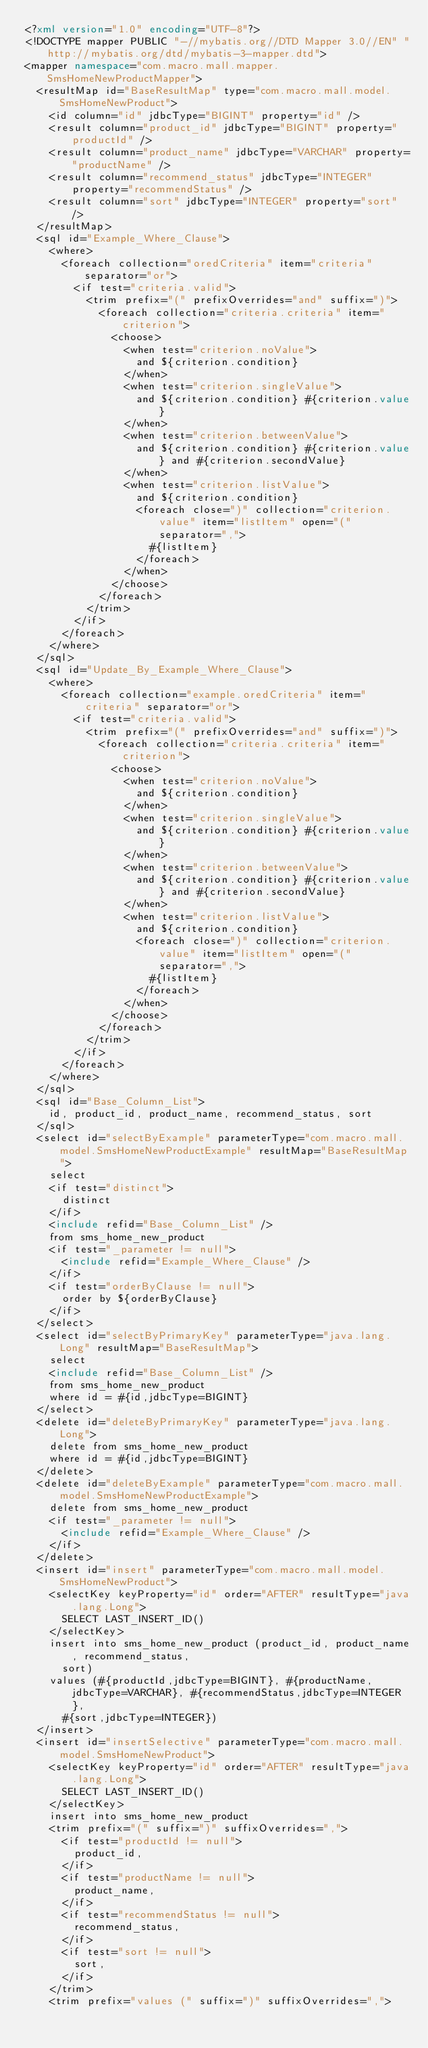<code> <loc_0><loc_0><loc_500><loc_500><_XML_><?xml version="1.0" encoding="UTF-8"?>
<!DOCTYPE mapper PUBLIC "-//mybatis.org//DTD Mapper 3.0//EN" "http://mybatis.org/dtd/mybatis-3-mapper.dtd">
<mapper namespace="com.macro.mall.mapper.SmsHomeNewProductMapper">
  <resultMap id="BaseResultMap" type="com.macro.mall.model.SmsHomeNewProduct">
    <id column="id" jdbcType="BIGINT" property="id" />
    <result column="product_id" jdbcType="BIGINT" property="productId" />
    <result column="product_name" jdbcType="VARCHAR" property="productName" />
    <result column="recommend_status" jdbcType="INTEGER" property="recommendStatus" />
    <result column="sort" jdbcType="INTEGER" property="sort" />
  </resultMap>
  <sql id="Example_Where_Clause">
    <where>
      <foreach collection="oredCriteria" item="criteria" separator="or">
        <if test="criteria.valid">
          <trim prefix="(" prefixOverrides="and" suffix=")">
            <foreach collection="criteria.criteria" item="criterion">
              <choose>
                <when test="criterion.noValue">
                  and ${criterion.condition}
                </when>
                <when test="criterion.singleValue">
                  and ${criterion.condition} #{criterion.value}
                </when>
                <when test="criterion.betweenValue">
                  and ${criterion.condition} #{criterion.value} and #{criterion.secondValue}
                </when>
                <when test="criterion.listValue">
                  and ${criterion.condition}
                  <foreach close=")" collection="criterion.value" item="listItem" open="(" separator=",">
                    #{listItem}
                  </foreach>
                </when>
              </choose>
            </foreach>
          </trim>
        </if>
      </foreach>
    </where>
  </sql>
  <sql id="Update_By_Example_Where_Clause">
    <where>
      <foreach collection="example.oredCriteria" item="criteria" separator="or">
        <if test="criteria.valid">
          <trim prefix="(" prefixOverrides="and" suffix=")">
            <foreach collection="criteria.criteria" item="criterion">
              <choose>
                <when test="criterion.noValue">
                  and ${criterion.condition}
                </when>
                <when test="criterion.singleValue">
                  and ${criterion.condition} #{criterion.value}
                </when>
                <when test="criterion.betweenValue">
                  and ${criterion.condition} #{criterion.value} and #{criterion.secondValue}
                </when>
                <when test="criterion.listValue">
                  and ${criterion.condition}
                  <foreach close=")" collection="criterion.value" item="listItem" open="(" separator=",">
                    #{listItem}
                  </foreach>
                </when>
              </choose>
            </foreach>
          </trim>
        </if>
      </foreach>
    </where>
  </sql>
  <sql id="Base_Column_List">
    id, product_id, product_name, recommend_status, sort
  </sql>
  <select id="selectByExample" parameterType="com.macro.mall.model.SmsHomeNewProductExample" resultMap="BaseResultMap">
    select
    <if test="distinct">
      distinct
    </if>
    <include refid="Base_Column_List" />
    from sms_home_new_product
    <if test="_parameter != null">
      <include refid="Example_Where_Clause" />
    </if>
    <if test="orderByClause != null">
      order by ${orderByClause}
    </if>
  </select>
  <select id="selectByPrimaryKey" parameterType="java.lang.Long" resultMap="BaseResultMap">
    select 
    <include refid="Base_Column_List" />
    from sms_home_new_product
    where id = #{id,jdbcType=BIGINT}
  </select>
  <delete id="deleteByPrimaryKey" parameterType="java.lang.Long">
    delete from sms_home_new_product
    where id = #{id,jdbcType=BIGINT}
  </delete>
  <delete id="deleteByExample" parameterType="com.macro.mall.model.SmsHomeNewProductExample">
    delete from sms_home_new_product
    <if test="_parameter != null">
      <include refid="Example_Where_Clause" />
    </if>
  </delete>
  <insert id="insert" parameterType="com.macro.mall.model.SmsHomeNewProduct">
    <selectKey keyProperty="id" order="AFTER" resultType="java.lang.Long">
      SELECT LAST_INSERT_ID()
    </selectKey>
    insert into sms_home_new_product (product_id, product_name, recommend_status, 
      sort)
    values (#{productId,jdbcType=BIGINT}, #{productName,jdbcType=VARCHAR}, #{recommendStatus,jdbcType=INTEGER}, 
      #{sort,jdbcType=INTEGER})
  </insert>
  <insert id="insertSelective" parameterType="com.macro.mall.model.SmsHomeNewProduct">
    <selectKey keyProperty="id" order="AFTER" resultType="java.lang.Long">
      SELECT LAST_INSERT_ID()
    </selectKey>
    insert into sms_home_new_product
    <trim prefix="(" suffix=")" suffixOverrides=",">
      <if test="productId != null">
        product_id,
      </if>
      <if test="productName != null">
        product_name,
      </if>
      <if test="recommendStatus != null">
        recommend_status,
      </if>
      <if test="sort != null">
        sort,
      </if>
    </trim>
    <trim prefix="values (" suffix=")" suffixOverrides=","></code> 